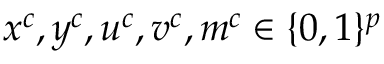<formula> <loc_0><loc_0><loc_500><loc_500>x ^ { c } , y ^ { c } , u ^ { c } , v ^ { c } , m ^ { c } \in \{ 0 , 1 \} ^ { p }</formula> 